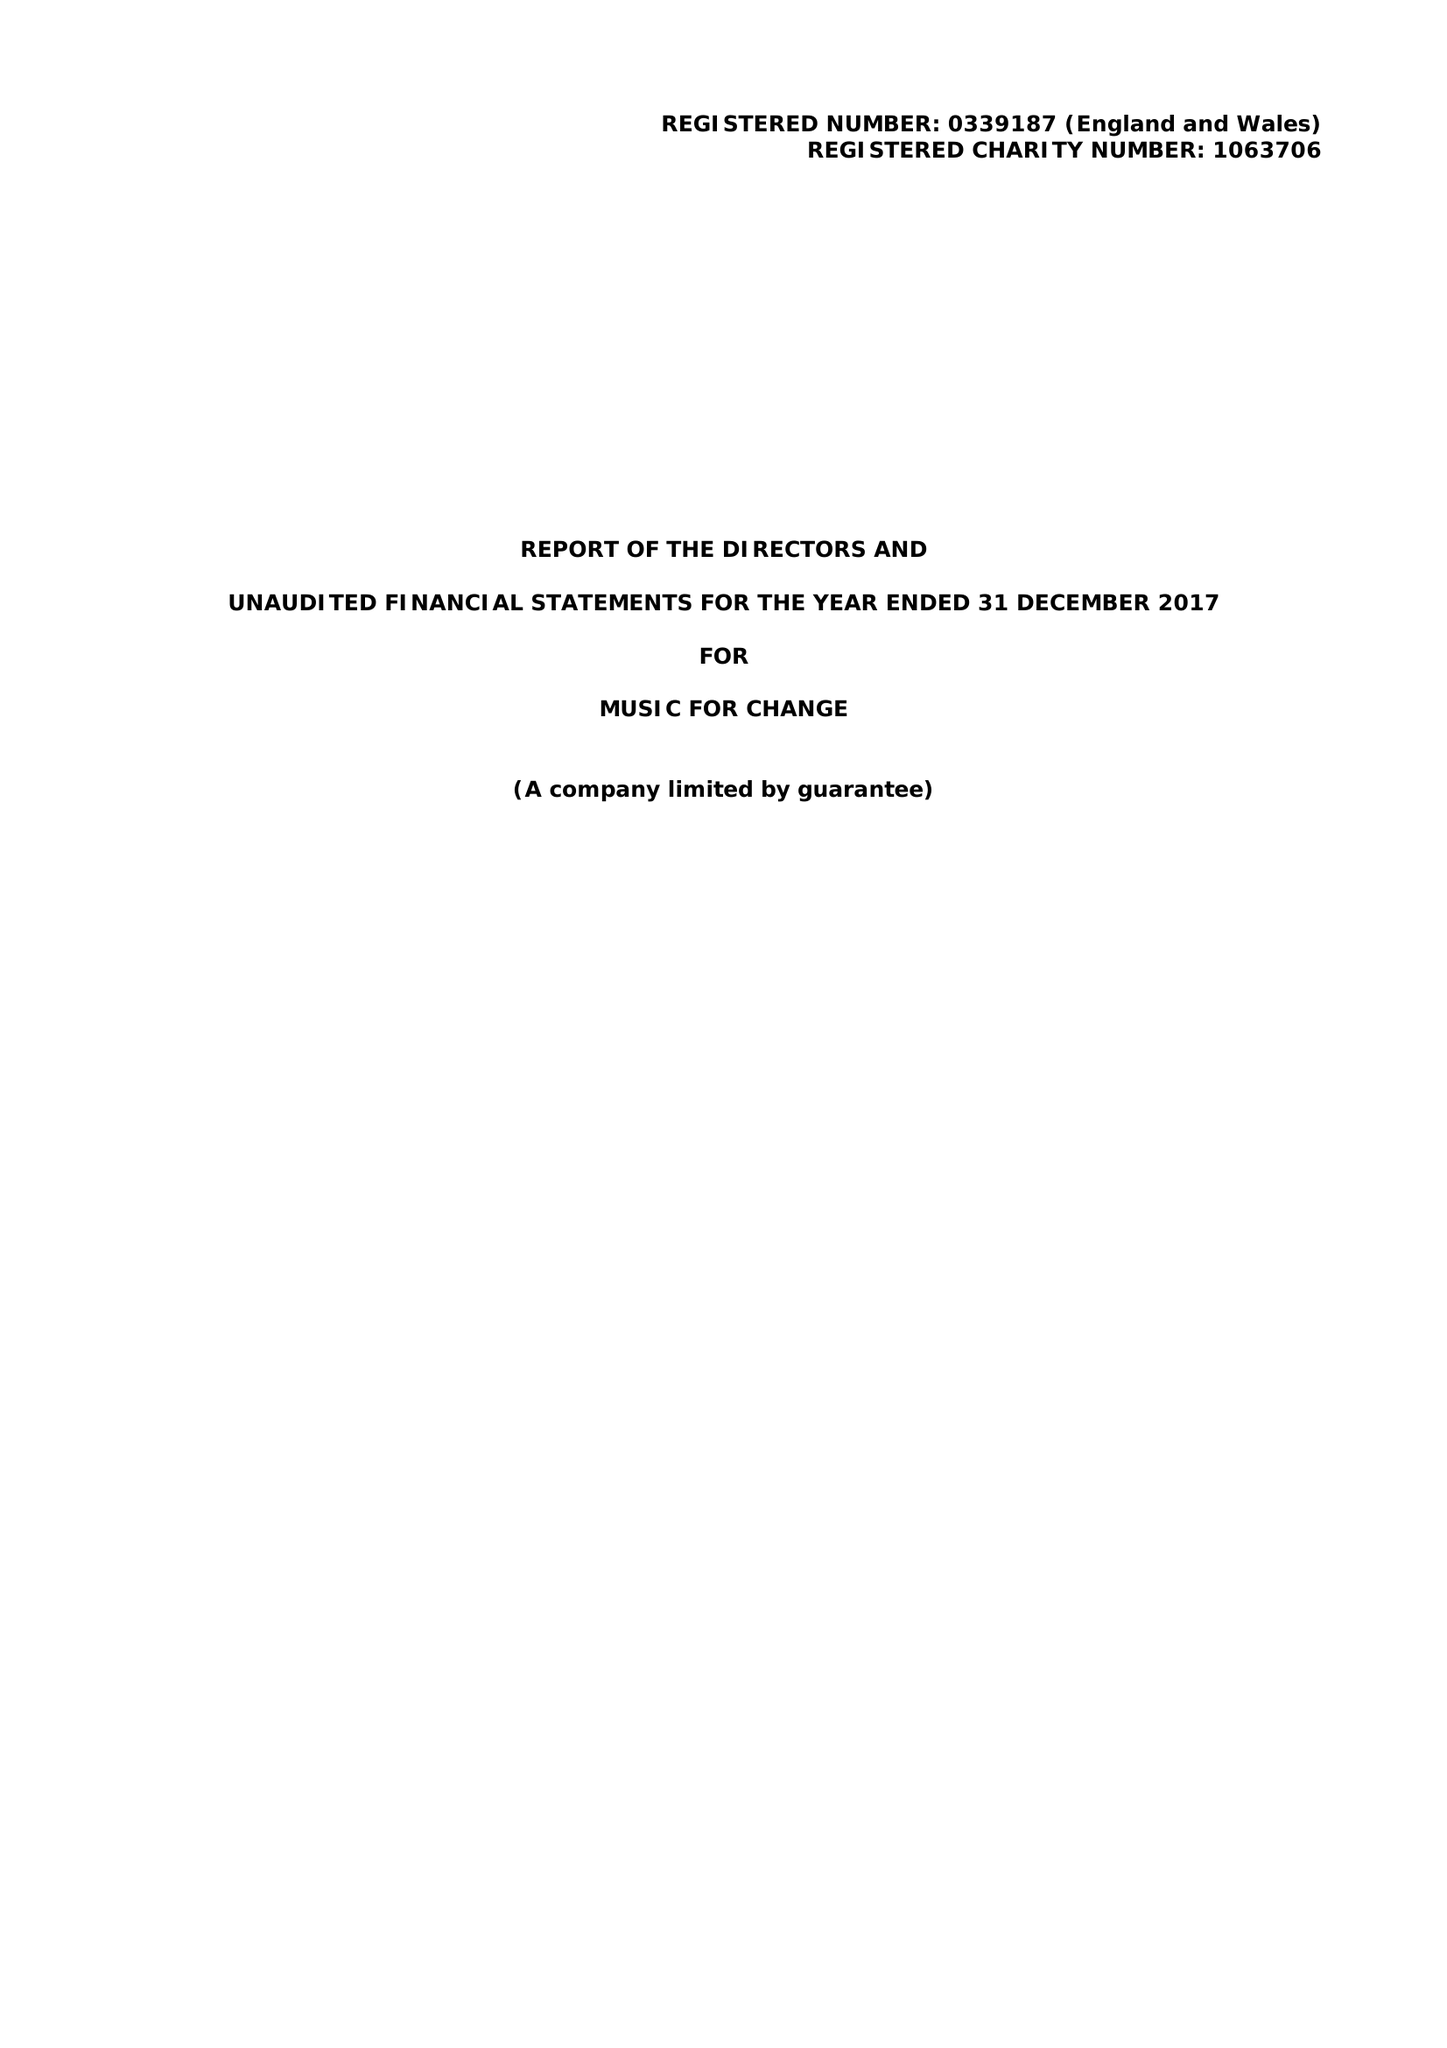What is the value for the income_annually_in_british_pounds?
Answer the question using a single word or phrase. 179378.00 